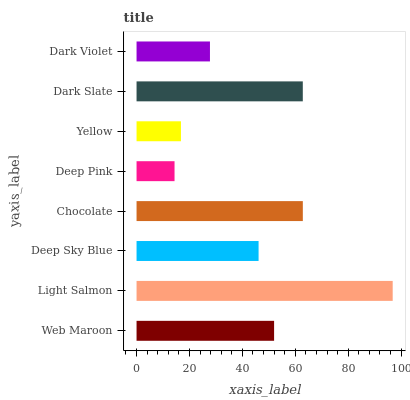Is Deep Pink the minimum?
Answer yes or no. Yes. Is Light Salmon the maximum?
Answer yes or no. Yes. Is Deep Sky Blue the minimum?
Answer yes or no. No. Is Deep Sky Blue the maximum?
Answer yes or no. No. Is Light Salmon greater than Deep Sky Blue?
Answer yes or no. Yes. Is Deep Sky Blue less than Light Salmon?
Answer yes or no. Yes. Is Deep Sky Blue greater than Light Salmon?
Answer yes or no. No. Is Light Salmon less than Deep Sky Blue?
Answer yes or no. No. Is Web Maroon the high median?
Answer yes or no. Yes. Is Deep Sky Blue the low median?
Answer yes or no. Yes. Is Dark Violet the high median?
Answer yes or no. No. Is Light Salmon the low median?
Answer yes or no. No. 